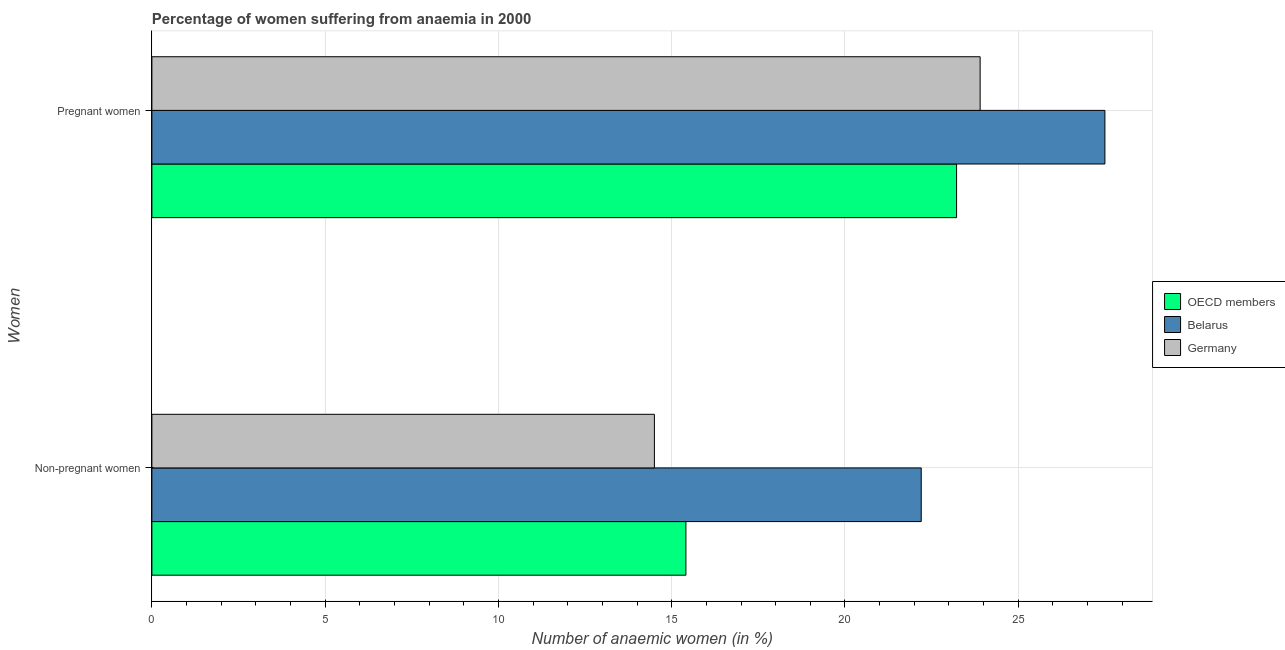How many bars are there on the 2nd tick from the bottom?
Provide a succinct answer. 3. What is the label of the 1st group of bars from the top?
Your answer should be compact. Pregnant women. What is the percentage of pregnant anaemic women in OECD members?
Make the answer very short. 23.22. In which country was the percentage of pregnant anaemic women maximum?
Provide a short and direct response. Belarus. In which country was the percentage of non-pregnant anaemic women minimum?
Give a very brief answer. Germany. What is the total percentage of non-pregnant anaemic women in the graph?
Provide a short and direct response. 52.11. What is the difference between the percentage of non-pregnant anaemic women in Germany and that in OECD members?
Your response must be concise. -0.91. What is the difference between the percentage of pregnant anaemic women in OECD members and the percentage of non-pregnant anaemic women in Belarus?
Make the answer very short. 1.02. What is the average percentage of pregnant anaemic women per country?
Your answer should be very brief. 24.87. What is the difference between the percentage of non-pregnant anaemic women and percentage of pregnant anaemic women in Belarus?
Your answer should be very brief. -5.3. What is the ratio of the percentage of non-pregnant anaemic women in Germany to that in OECD members?
Your answer should be very brief. 0.94. In how many countries, is the percentage of non-pregnant anaemic women greater than the average percentage of non-pregnant anaemic women taken over all countries?
Your answer should be compact. 1. What does the 1st bar from the bottom in Non-pregnant women represents?
Ensure brevity in your answer.  OECD members. How many bars are there?
Your response must be concise. 6. Are all the bars in the graph horizontal?
Give a very brief answer. Yes. Are the values on the major ticks of X-axis written in scientific E-notation?
Your response must be concise. No. How many legend labels are there?
Give a very brief answer. 3. What is the title of the graph?
Your response must be concise. Percentage of women suffering from anaemia in 2000. What is the label or title of the X-axis?
Ensure brevity in your answer.  Number of anaemic women (in %). What is the label or title of the Y-axis?
Provide a short and direct response. Women. What is the Number of anaemic women (in %) in OECD members in Non-pregnant women?
Provide a succinct answer. 15.41. What is the Number of anaemic women (in %) in Belarus in Non-pregnant women?
Your response must be concise. 22.2. What is the Number of anaemic women (in %) of Germany in Non-pregnant women?
Keep it short and to the point. 14.5. What is the Number of anaemic women (in %) in OECD members in Pregnant women?
Your response must be concise. 23.22. What is the Number of anaemic women (in %) in Belarus in Pregnant women?
Provide a succinct answer. 27.5. What is the Number of anaemic women (in %) in Germany in Pregnant women?
Offer a very short reply. 23.9. Across all Women, what is the maximum Number of anaemic women (in %) of OECD members?
Provide a short and direct response. 23.22. Across all Women, what is the maximum Number of anaemic women (in %) in Germany?
Keep it short and to the point. 23.9. Across all Women, what is the minimum Number of anaemic women (in %) in OECD members?
Give a very brief answer. 15.41. Across all Women, what is the minimum Number of anaemic women (in %) in Belarus?
Your answer should be very brief. 22.2. What is the total Number of anaemic women (in %) in OECD members in the graph?
Provide a succinct answer. 38.63. What is the total Number of anaemic women (in %) of Belarus in the graph?
Provide a succinct answer. 49.7. What is the total Number of anaemic women (in %) of Germany in the graph?
Offer a very short reply. 38.4. What is the difference between the Number of anaemic women (in %) in OECD members in Non-pregnant women and that in Pregnant women?
Make the answer very short. -7.81. What is the difference between the Number of anaemic women (in %) of Germany in Non-pregnant women and that in Pregnant women?
Make the answer very short. -9.4. What is the difference between the Number of anaemic women (in %) in OECD members in Non-pregnant women and the Number of anaemic women (in %) in Belarus in Pregnant women?
Your response must be concise. -12.09. What is the difference between the Number of anaemic women (in %) in OECD members in Non-pregnant women and the Number of anaemic women (in %) in Germany in Pregnant women?
Give a very brief answer. -8.49. What is the difference between the Number of anaemic women (in %) in Belarus in Non-pregnant women and the Number of anaemic women (in %) in Germany in Pregnant women?
Your answer should be very brief. -1.7. What is the average Number of anaemic women (in %) in OECD members per Women?
Provide a short and direct response. 19.31. What is the average Number of anaemic women (in %) in Belarus per Women?
Your answer should be very brief. 24.85. What is the average Number of anaemic women (in %) in Germany per Women?
Your answer should be compact. 19.2. What is the difference between the Number of anaemic women (in %) in OECD members and Number of anaemic women (in %) in Belarus in Non-pregnant women?
Offer a terse response. -6.79. What is the difference between the Number of anaemic women (in %) in OECD members and Number of anaemic women (in %) in Germany in Non-pregnant women?
Your answer should be compact. 0.91. What is the difference between the Number of anaemic women (in %) in Belarus and Number of anaemic women (in %) in Germany in Non-pregnant women?
Make the answer very short. 7.7. What is the difference between the Number of anaemic women (in %) of OECD members and Number of anaemic women (in %) of Belarus in Pregnant women?
Make the answer very short. -4.28. What is the difference between the Number of anaemic women (in %) of OECD members and Number of anaemic women (in %) of Germany in Pregnant women?
Give a very brief answer. -0.68. What is the ratio of the Number of anaemic women (in %) of OECD members in Non-pregnant women to that in Pregnant women?
Your answer should be very brief. 0.66. What is the ratio of the Number of anaemic women (in %) in Belarus in Non-pregnant women to that in Pregnant women?
Ensure brevity in your answer.  0.81. What is the ratio of the Number of anaemic women (in %) of Germany in Non-pregnant women to that in Pregnant women?
Make the answer very short. 0.61. What is the difference between the highest and the second highest Number of anaemic women (in %) of OECD members?
Ensure brevity in your answer.  7.81. What is the difference between the highest and the second highest Number of anaemic women (in %) in Germany?
Provide a short and direct response. 9.4. What is the difference between the highest and the lowest Number of anaemic women (in %) in OECD members?
Provide a succinct answer. 7.81. What is the difference between the highest and the lowest Number of anaemic women (in %) in Germany?
Provide a short and direct response. 9.4. 